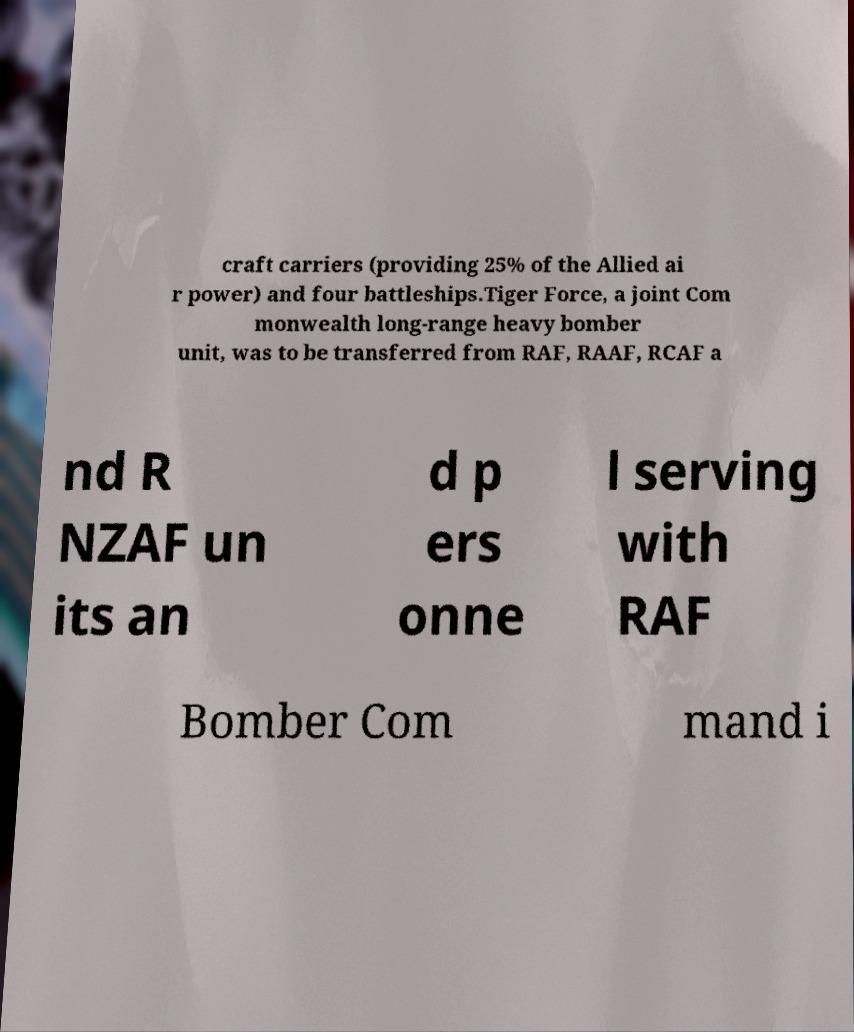For documentation purposes, I need the text within this image transcribed. Could you provide that? craft carriers (providing 25% of the Allied ai r power) and four battleships.Tiger Force, a joint Com monwealth long-range heavy bomber unit, was to be transferred from RAF, RAAF, RCAF a nd R NZAF un its an d p ers onne l serving with RAF Bomber Com mand i 